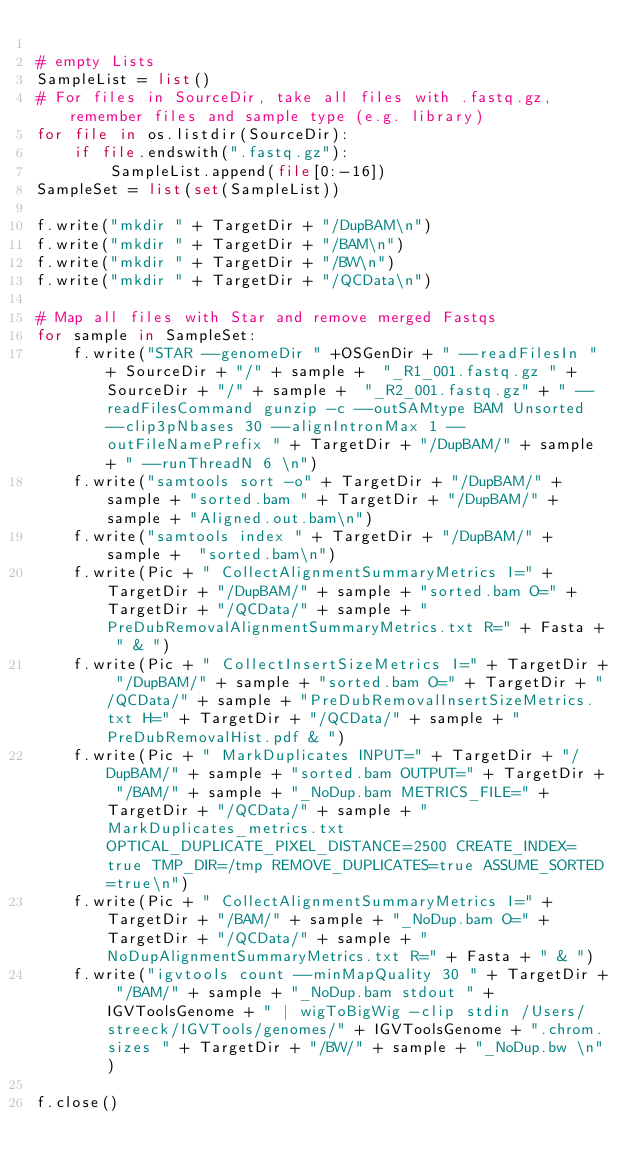<code> <loc_0><loc_0><loc_500><loc_500><_Python_>
# empty Lists
SampleList = list()
# For files in SourceDir, take all files with .fastq.gz, remember files and sample type (e.g. library)
for file in os.listdir(SourceDir):
    if file.endswith(".fastq.gz"):
        SampleList.append(file[0:-16])
SampleSet = list(set(SampleList))

f.write("mkdir " + TargetDir + "/DupBAM\n")
f.write("mkdir " + TargetDir + "/BAM\n")
f.write("mkdir " + TargetDir + "/BW\n")
f.write("mkdir " + TargetDir + "/QCData\n")

# Map all files with Star and remove merged Fastqs
for sample in SampleSet:
    f.write("STAR --genomeDir " +OSGenDir + " --readFilesIn " + SourceDir + "/" + sample +  "_R1_001.fastq.gz " + SourceDir + "/" + sample +  "_R2_001.fastq.gz" + " --readFilesCommand gunzip -c --outSAMtype BAM Unsorted --clip3pNbases 30 --alignIntronMax 1 --outFileNamePrefix " + TargetDir + "/DupBAM/" + sample + " --runThreadN 6 \n")
    f.write("samtools sort -o" + TargetDir + "/DupBAM/" + sample + "sorted.bam " + TargetDir + "/DupBAM/" + sample + "Aligned.out.bam\n")
    f.write("samtools index " + TargetDir + "/DupBAM/" + sample +  "sorted.bam\n")
    f.write(Pic + " CollectAlignmentSummaryMetrics I=" + TargetDir + "/DupBAM/" + sample + "sorted.bam O=" + TargetDir + "/QCData/" + sample + "PreDubRemovalAlignmentSummaryMetrics.txt R=" + Fasta + " & ")
    f.write(Pic + " CollectInsertSizeMetrics I=" + TargetDir + "/DupBAM/" + sample + "sorted.bam O=" + TargetDir + "/QCData/" + sample + "PreDubRemovalInsertSizeMetrics.txt H=" + TargetDir + "/QCData/" + sample + "PreDubRemovalHist.pdf & ")
    f.write(Pic + " MarkDuplicates INPUT=" + TargetDir + "/DupBAM/" + sample + "sorted.bam OUTPUT=" + TargetDir + "/BAM/" + sample + "_NoDup.bam METRICS_FILE=" + TargetDir + "/QCData/" + sample + "MarkDuplicates_metrics.txt OPTICAL_DUPLICATE_PIXEL_DISTANCE=2500 CREATE_INDEX=true TMP_DIR=/tmp REMOVE_DUPLICATES=true ASSUME_SORTED=true\n")
    f.write(Pic + " CollectAlignmentSummaryMetrics I=" + TargetDir + "/BAM/" + sample + "_NoDup.bam O=" + TargetDir + "/QCData/" + sample + "NoDupAlignmentSummaryMetrics.txt R=" + Fasta + " & ")
    f.write("igvtools count --minMapQuality 30 " + TargetDir + "/BAM/" + sample + "_NoDup.bam stdout " + IGVToolsGenome + " | wigToBigWig -clip stdin /Users/streeck/IGVTools/genomes/" + IGVToolsGenome + ".chrom.sizes " + TargetDir + "/BW/" + sample + "_NoDup.bw \n")

f.close()

</code> 